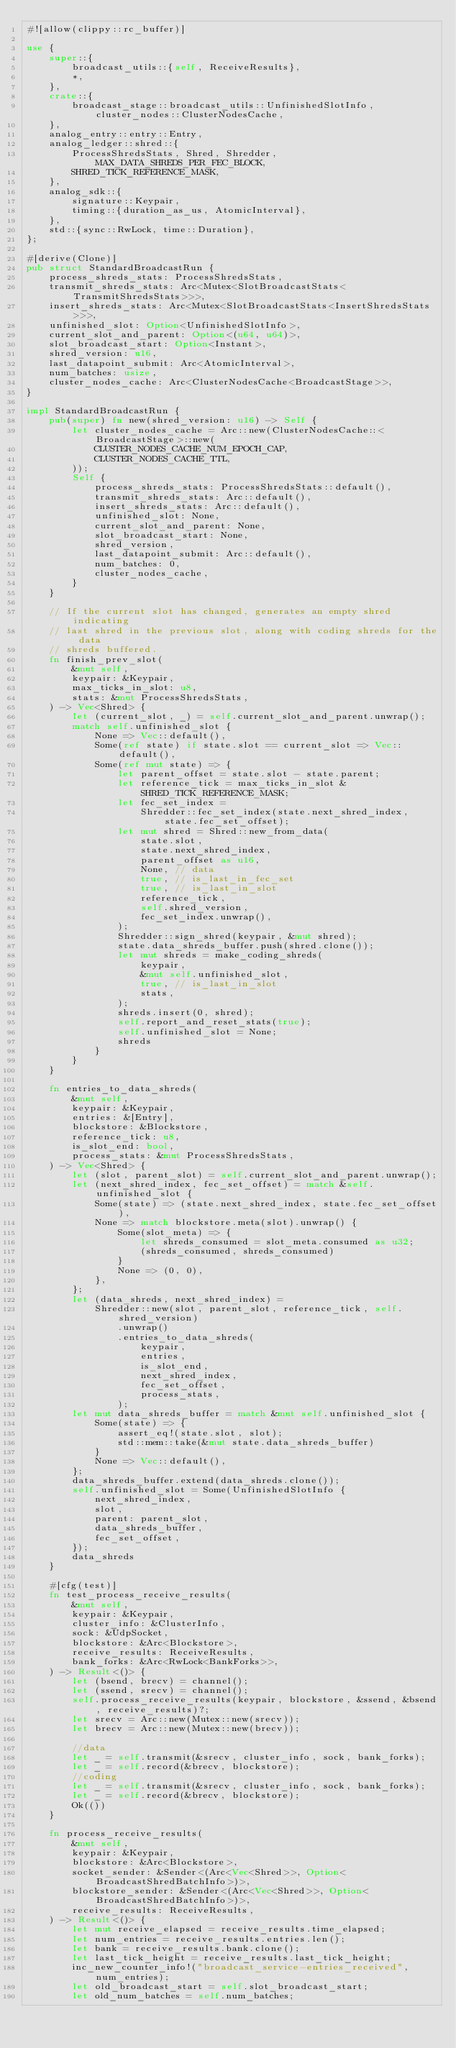Convert code to text. <code><loc_0><loc_0><loc_500><loc_500><_Rust_>#![allow(clippy::rc_buffer)]

use {
    super::{
        broadcast_utils::{self, ReceiveResults},
        *,
    },
    crate::{
        broadcast_stage::broadcast_utils::UnfinishedSlotInfo, cluster_nodes::ClusterNodesCache,
    },
    analog_entry::entry::Entry,
    analog_ledger::shred::{
        ProcessShredsStats, Shred, Shredder, MAX_DATA_SHREDS_PER_FEC_BLOCK,
        SHRED_TICK_REFERENCE_MASK,
    },
    analog_sdk::{
        signature::Keypair,
        timing::{duration_as_us, AtomicInterval},
    },
    std::{sync::RwLock, time::Duration},
};

#[derive(Clone)]
pub struct StandardBroadcastRun {
    process_shreds_stats: ProcessShredsStats,
    transmit_shreds_stats: Arc<Mutex<SlotBroadcastStats<TransmitShredsStats>>>,
    insert_shreds_stats: Arc<Mutex<SlotBroadcastStats<InsertShredsStats>>>,
    unfinished_slot: Option<UnfinishedSlotInfo>,
    current_slot_and_parent: Option<(u64, u64)>,
    slot_broadcast_start: Option<Instant>,
    shred_version: u16,
    last_datapoint_submit: Arc<AtomicInterval>,
    num_batches: usize,
    cluster_nodes_cache: Arc<ClusterNodesCache<BroadcastStage>>,
}

impl StandardBroadcastRun {
    pub(super) fn new(shred_version: u16) -> Self {
        let cluster_nodes_cache = Arc::new(ClusterNodesCache::<BroadcastStage>::new(
            CLUSTER_NODES_CACHE_NUM_EPOCH_CAP,
            CLUSTER_NODES_CACHE_TTL,
        ));
        Self {
            process_shreds_stats: ProcessShredsStats::default(),
            transmit_shreds_stats: Arc::default(),
            insert_shreds_stats: Arc::default(),
            unfinished_slot: None,
            current_slot_and_parent: None,
            slot_broadcast_start: None,
            shred_version,
            last_datapoint_submit: Arc::default(),
            num_batches: 0,
            cluster_nodes_cache,
        }
    }

    // If the current slot has changed, generates an empty shred indicating
    // last shred in the previous slot, along with coding shreds for the data
    // shreds buffered.
    fn finish_prev_slot(
        &mut self,
        keypair: &Keypair,
        max_ticks_in_slot: u8,
        stats: &mut ProcessShredsStats,
    ) -> Vec<Shred> {
        let (current_slot, _) = self.current_slot_and_parent.unwrap();
        match self.unfinished_slot {
            None => Vec::default(),
            Some(ref state) if state.slot == current_slot => Vec::default(),
            Some(ref mut state) => {
                let parent_offset = state.slot - state.parent;
                let reference_tick = max_ticks_in_slot & SHRED_TICK_REFERENCE_MASK;
                let fec_set_index =
                    Shredder::fec_set_index(state.next_shred_index, state.fec_set_offset);
                let mut shred = Shred::new_from_data(
                    state.slot,
                    state.next_shred_index,
                    parent_offset as u16,
                    None, // data
                    true, // is_last_in_fec_set
                    true, // is_last_in_slot
                    reference_tick,
                    self.shred_version,
                    fec_set_index.unwrap(),
                );
                Shredder::sign_shred(keypair, &mut shred);
                state.data_shreds_buffer.push(shred.clone());
                let mut shreds = make_coding_shreds(
                    keypair,
                    &mut self.unfinished_slot,
                    true, // is_last_in_slot
                    stats,
                );
                shreds.insert(0, shred);
                self.report_and_reset_stats(true);
                self.unfinished_slot = None;
                shreds
            }
        }
    }

    fn entries_to_data_shreds(
        &mut self,
        keypair: &Keypair,
        entries: &[Entry],
        blockstore: &Blockstore,
        reference_tick: u8,
        is_slot_end: bool,
        process_stats: &mut ProcessShredsStats,
    ) -> Vec<Shred> {
        let (slot, parent_slot) = self.current_slot_and_parent.unwrap();
        let (next_shred_index, fec_set_offset) = match &self.unfinished_slot {
            Some(state) => (state.next_shred_index, state.fec_set_offset),
            None => match blockstore.meta(slot).unwrap() {
                Some(slot_meta) => {
                    let shreds_consumed = slot_meta.consumed as u32;
                    (shreds_consumed, shreds_consumed)
                }
                None => (0, 0),
            },
        };
        let (data_shreds, next_shred_index) =
            Shredder::new(slot, parent_slot, reference_tick, self.shred_version)
                .unwrap()
                .entries_to_data_shreds(
                    keypair,
                    entries,
                    is_slot_end,
                    next_shred_index,
                    fec_set_offset,
                    process_stats,
                );
        let mut data_shreds_buffer = match &mut self.unfinished_slot {
            Some(state) => {
                assert_eq!(state.slot, slot);
                std::mem::take(&mut state.data_shreds_buffer)
            }
            None => Vec::default(),
        };
        data_shreds_buffer.extend(data_shreds.clone());
        self.unfinished_slot = Some(UnfinishedSlotInfo {
            next_shred_index,
            slot,
            parent: parent_slot,
            data_shreds_buffer,
            fec_set_offset,
        });
        data_shreds
    }

    #[cfg(test)]
    fn test_process_receive_results(
        &mut self,
        keypair: &Keypair,
        cluster_info: &ClusterInfo,
        sock: &UdpSocket,
        blockstore: &Arc<Blockstore>,
        receive_results: ReceiveResults,
        bank_forks: &Arc<RwLock<BankForks>>,
    ) -> Result<()> {
        let (bsend, brecv) = channel();
        let (ssend, srecv) = channel();
        self.process_receive_results(keypair, blockstore, &ssend, &bsend, receive_results)?;
        let srecv = Arc::new(Mutex::new(srecv));
        let brecv = Arc::new(Mutex::new(brecv));

        //data
        let _ = self.transmit(&srecv, cluster_info, sock, bank_forks);
        let _ = self.record(&brecv, blockstore);
        //coding
        let _ = self.transmit(&srecv, cluster_info, sock, bank_forks);
        let _ = self.record(&brecv, blockstore);
        Ok(())
    }

    fn process_receive_results(
        &mut self,
        keypair: &Keypair,
        blockstore: &Arc<Blockstore>,
        socket_sender: &Sender<(Arc<Vec<Shred>>, Option<BroadcastShredBatchInfo>)>,
        blockstore_sender: &Sender<(Arc<Vec<Shred>>, Option<BroadcastShredBatchInfo>)>,
        receive_results: ReceiveResults,
    ) -> Result<()> {
        let mut receive_elapsed = receive_results.time_elapsed;
        let num_entries = receive_results.entries.len();
        let bank = receive_results.bank.clone();
        let last_tick_height = receive_results.last_tick_height;
        inc_new_counter_info!("broadcast_service-entries_received", num_entries);
        let old_broadcast_start = self.slot_broadcast_start;
        let old_num_batches = self.num_batches;</code> 